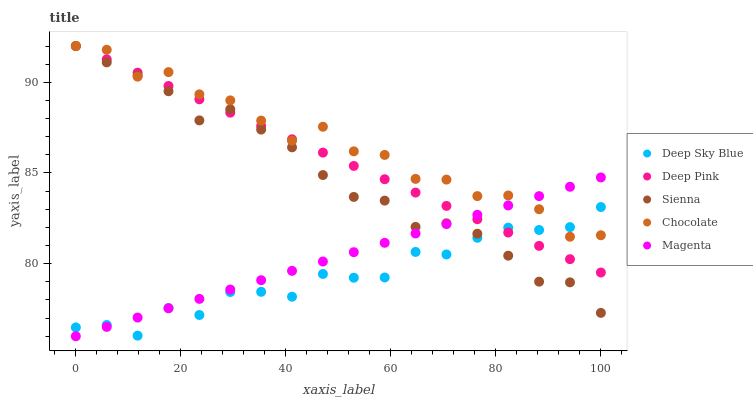Does Deep Sky Blue have the minimum area under the curve?
Answer yes or no. Yes. Does Chocolate have the maximum area under the curve?
Answer yes or no. Yes. Does Magenta have the minimum area under the curve?
Answer yes or no. No. Does Magenta have the maximum area under the curve?
Answer yes or no. No. Is Deep Pink the smoothest?
Answer yes or no. Yes. Is Chocolate the roughest?
Answer yes or no. Yes. Is Magenta the smoothest?
Answer yes or no. No. Is Magenta the roughest?
Answer yes or no. No. Does Magenta have the lowest value?
Answer yes or no. Yes. Does Deep Pink have the lowest value?
Answer yes or no. No. Does Chocolate have the highest value?
Answer yes or no. Yes. Does Magenta have the highest value?
Answer yes or no. No. Does Deep Pink intersect Chocolate?
Answer yes or no. Yes. Is Deep Pink less than Chocolate?
Answer yes or no. No. Is Deep Pink greater than Chocolate?
Answer yes or no. No. 